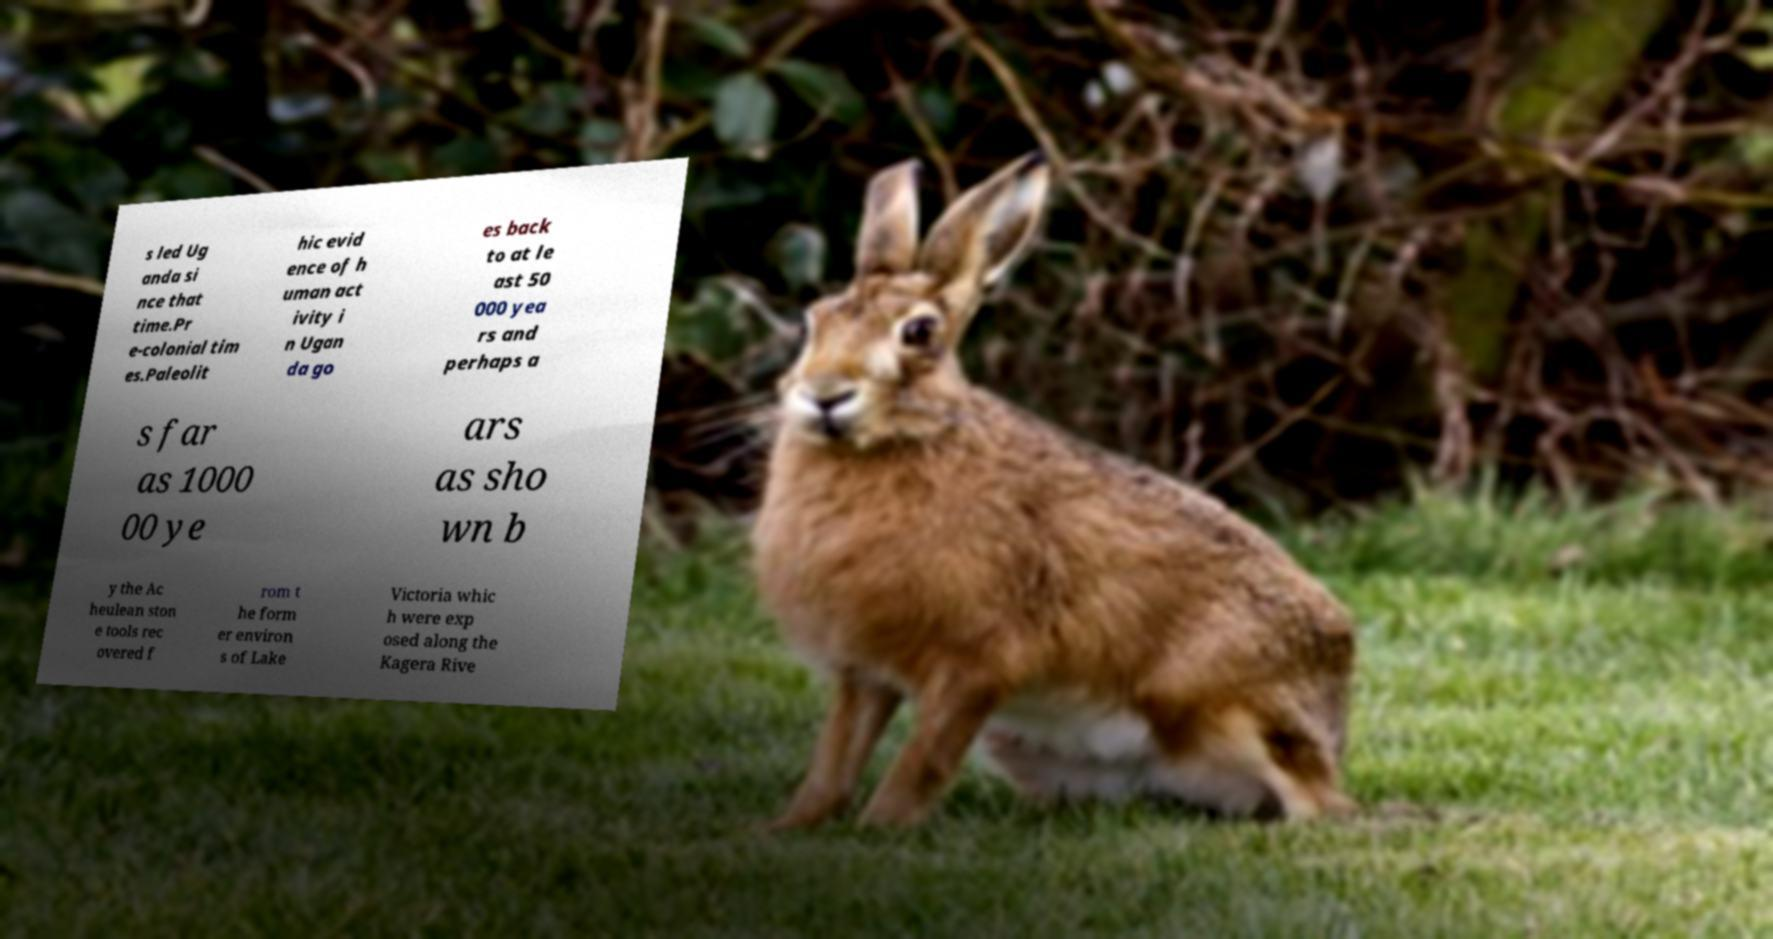Please identify and transcribe the text found in this image. s led Ug anda si nce that time.Pr e-colonial tim es.Paleolit hic evid ence of h uman act ivity i n Ugan da go es back to at le ast 50 000 yea rs and perhaps a s far as 1000 00 ye ars as sho wn b y the Ac heulean ston e tools rec overed f rom t he form er environ s of Lake Victoria whic h were exp osed along the Kagera Rive 